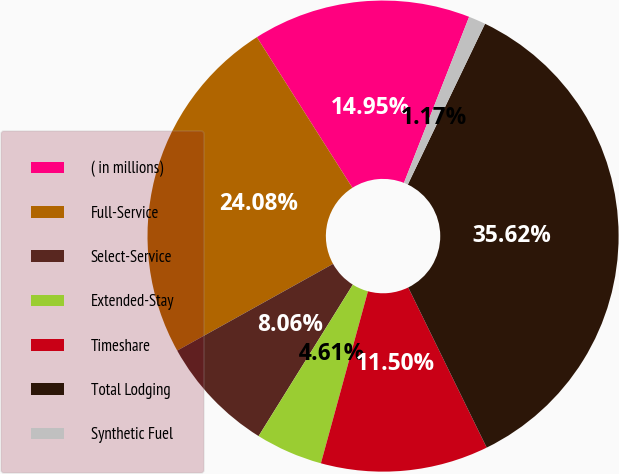Convert chart. <chart><loc_0><loc_0><loc_500><loc_500><pie_chart><fcel>( in millions)<fcel>Full-Service<fcel>Select-Service<fcel>Extended-Stay<fcel>Timeshare<fcel>Total Lodging<fcel>Synthetic Fuel<nl><fcel>14.95%<fcel>24.08%<fcel>8.06%<fcel>4.61%<fcel>11.5%<fcel>35.62%<fcel>1.17%<nl></chart> 